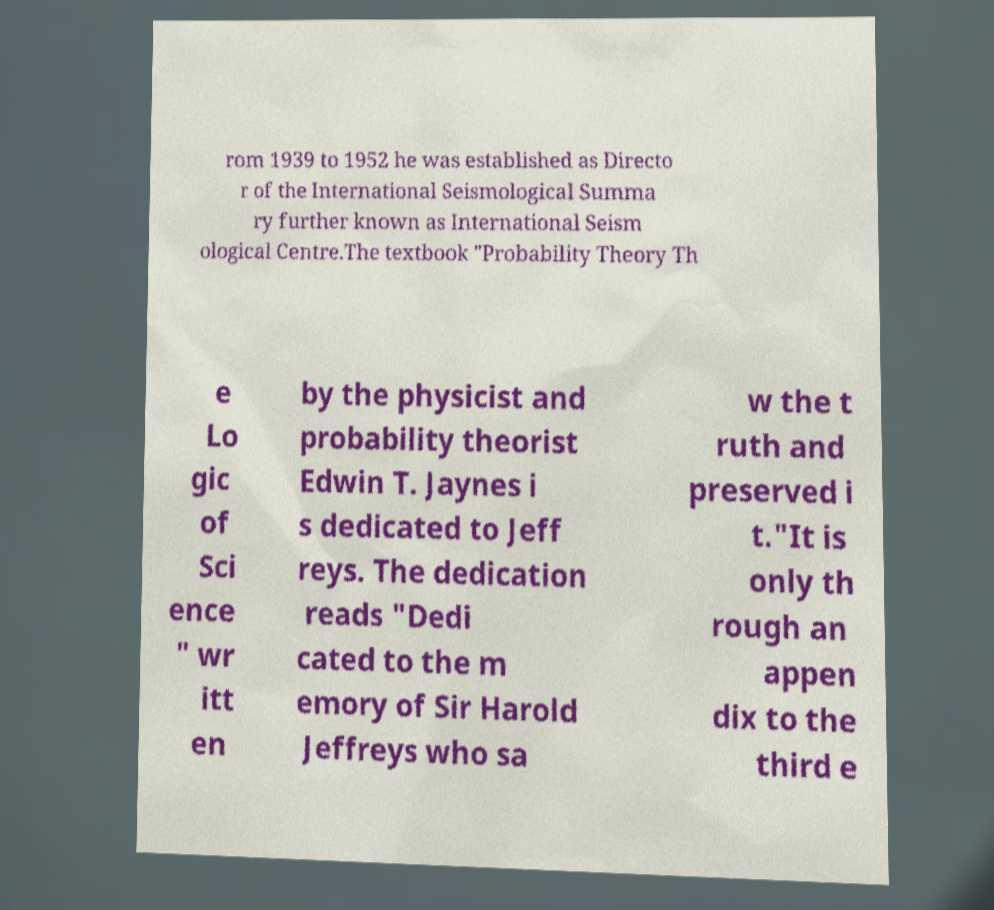Please identify and transcribe the text found in this image. rom 1939 to 1952 he was established as Directo r of the International Seismological Summa ry further known as International Seism ological Centre.The textbook "Probability Theory Th e Lo gic of Sci ence " wr itt en by the physicist and probability theorist Edwin T. Jaynes i s dedicated to Jeff reys. The dedication reads "Dedi cated to the m emory of Sir Harold Jeffreys who sa w the t ruth and preserved i t."It is only th rough an appen dix to the third e 